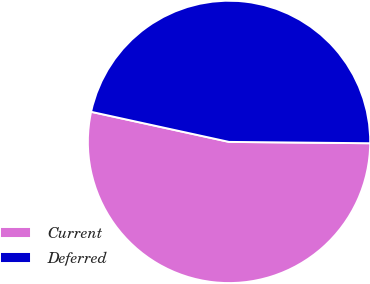<chart> <loc_0><loc_0><loc_500><loc_500><pie_chart><fcel>Current<fcel>Deferred<nl><fcel>53.27%<fcel>46.73%<nl></chart> 